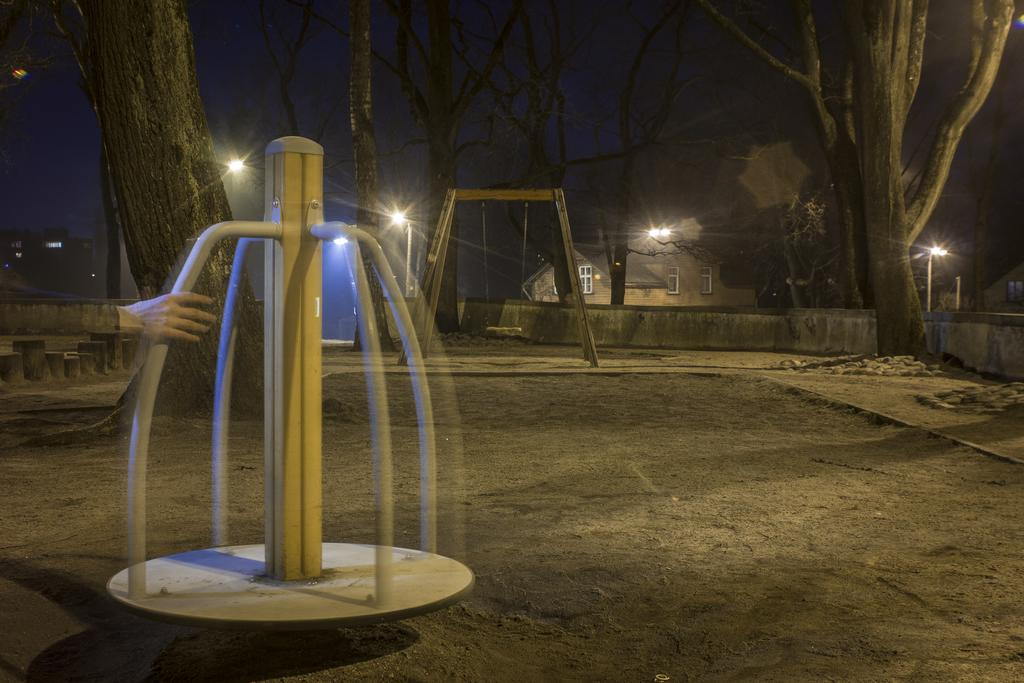What is the person in the image holding? The person is holding a fun ride in the image. What type of lighting is present in the image? Electric lights are visible in the image. What type of structures can be seen in the image? Street poles and buildings are present in the image. What type of natural elements can be seen in the image? Trees are visible in the image. What part of the natural environment is visible in the image? The sky is visible in the image. What type of shade is provided by the rake in the image? There is no rake present in the image, so no shade is provided by a rake. 